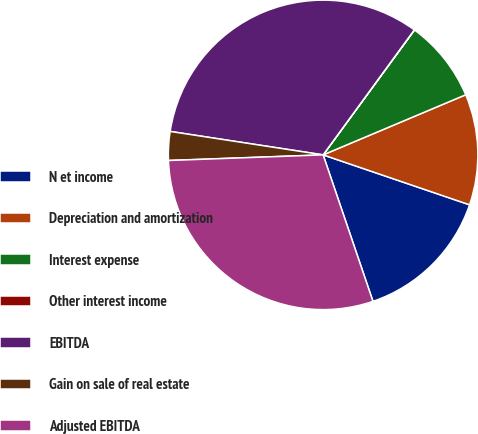<chart> <loc_0><loc_0><loc_500><loc_500><pie_chart><fcel>N et income<fcel>Depreciation and amortization<fcel>Interest expense<fcel>Other interest income<fcel>EBITDA<fcel>Gain on sale of real estate<fcel>Adjusted EBITDA<nl><fcel>14.55%<fcel>11.58%<fcel>8.6%<fcel>0.02%<fcel>32.61%<fcel>3.0%<fcel>29.64%<nl></chart> 